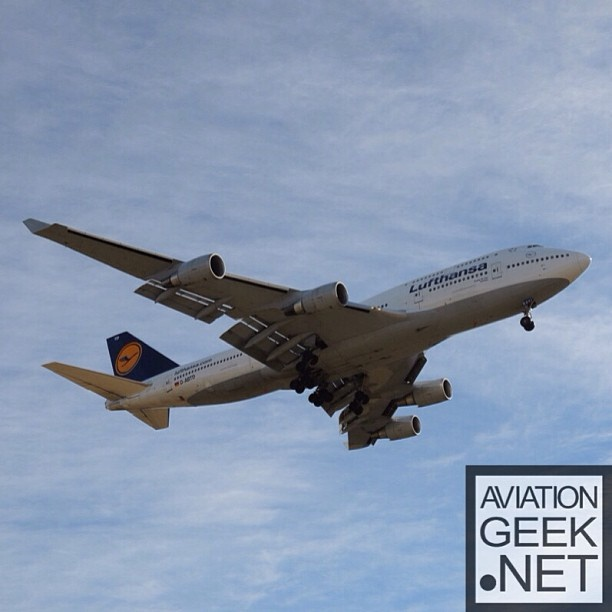Describe the objects in this image and their specific colors. I can see a airplane in gray and black tones in this image. 